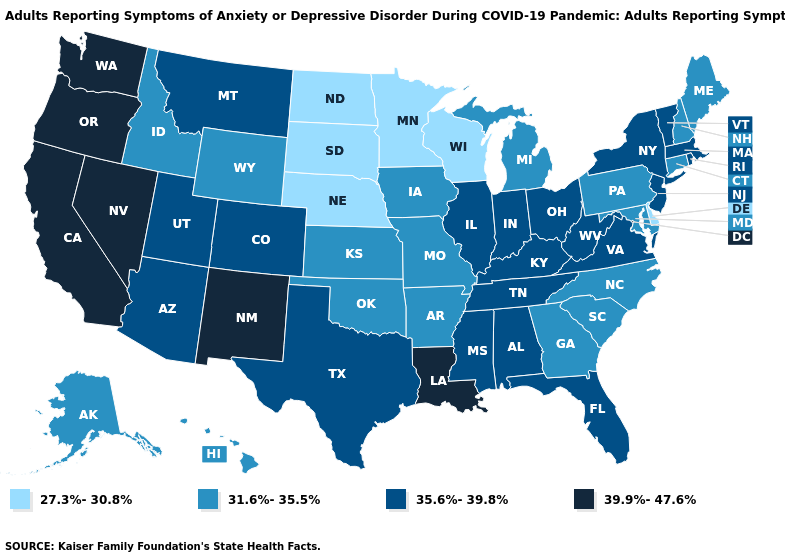Does Hawaii have a lower value than Wyoming?
Quick response, please. No. How many symbols are there in the legend?
Be succinct. 4. What is the value of Tennessee?
Concise answer only. 35.6%-39.8%. Does Delaware have the lowest value in the USA?
Answer briefly. Yes. Which states have the highest value in the USA?
Keep it brief. California, Louisiana, Nevada, New Mexico, Oregon, Washington. Does Mississippi have a lower value than Colorado?
Be succinct. No. What is the value of Nebraska?
Be succinct. 27.3%-30.8%. Name the states that have a value in the range 31.6%-35.5%?
Quick response, please. Alaska, Arkansas, Connecticut, Georgia, Hawaii, Idaho, Iowa, Kansas, Maine, Maryland, Michigan, Missouri, New Hampshire, North Carolina, Oklahoma, Pennsylvania, South Carolina, Wyoming. Does Arizona have the highest value in the West?
Be succinct. No. Name the states that have a value in the range 27.3%-30.8%?
Be succinct. Delaware, Minnesota, Nebraska, North Dakota, South Dakota, Wisconsin. Name the states that have a value in the range 35.6%-39.8%?
Answer briefly. Alabama, Arizona, Colorado, Florida, Illinois, Indiana, Kentucky, Massachusetts, Mississippi, Montana, New Jersey, New York, Ohio, Rhode Island, Tennessee, Texas, Utah, Vermont, Virginia, West Virginia. Does Massachusetts have the highest value in the Northeast?
Give a very brief answer. Yes. Which states have the lowest value in the Northeast?
Short answer required. Connecticut, Maine, New Hampshire, Pennsylvania. Name the states that have a value in the range 39.9%-47.6%?
Quick response, please. California, Louisiana, Nevada, New Mexico, Oregon, Washington. What is the highest value in states that border Nebraska?
Be succinct. 35.6%-39.8%. 